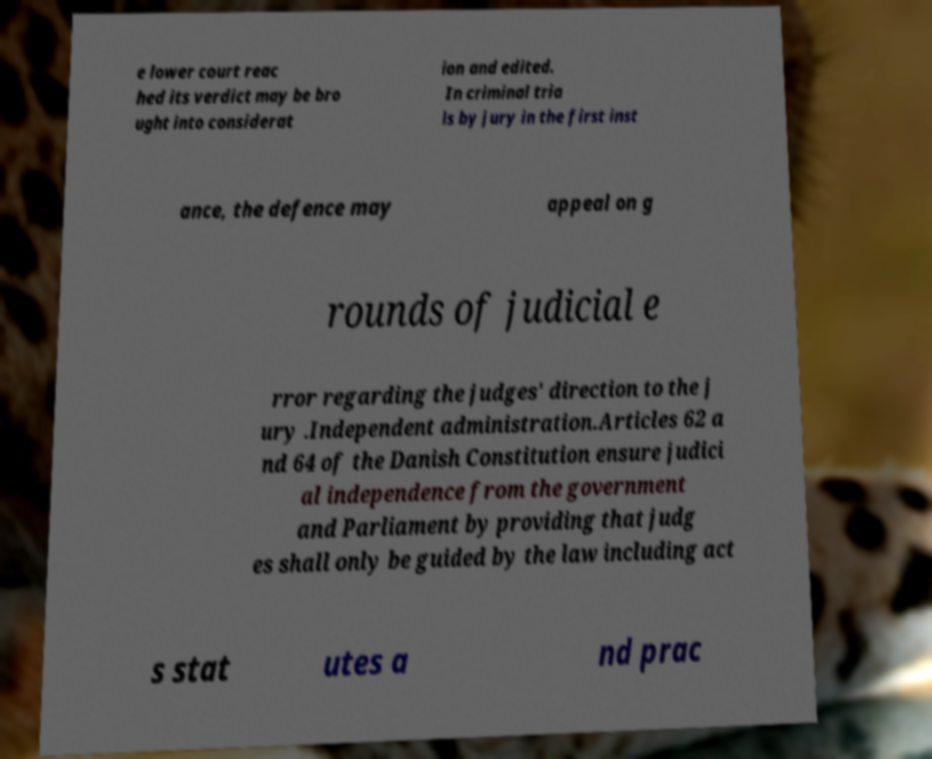There's text embedded in this image that I need extracted. Can you transcribe it verbatim? e lower court reac hed its verdict may be bro ught into considerat ion and edited. In criminal tria ls by jury in the first inst ance, the defence may appeal on g rounds of judicial e rror regarding the judges' direction to the j ury .Independent administration.Articles 62 a nd 64 of the Danish Constitution ensure judici al independence from the government and Parliament by providing that judg es shall only be guided by the law including act s stat utes a nd prac 